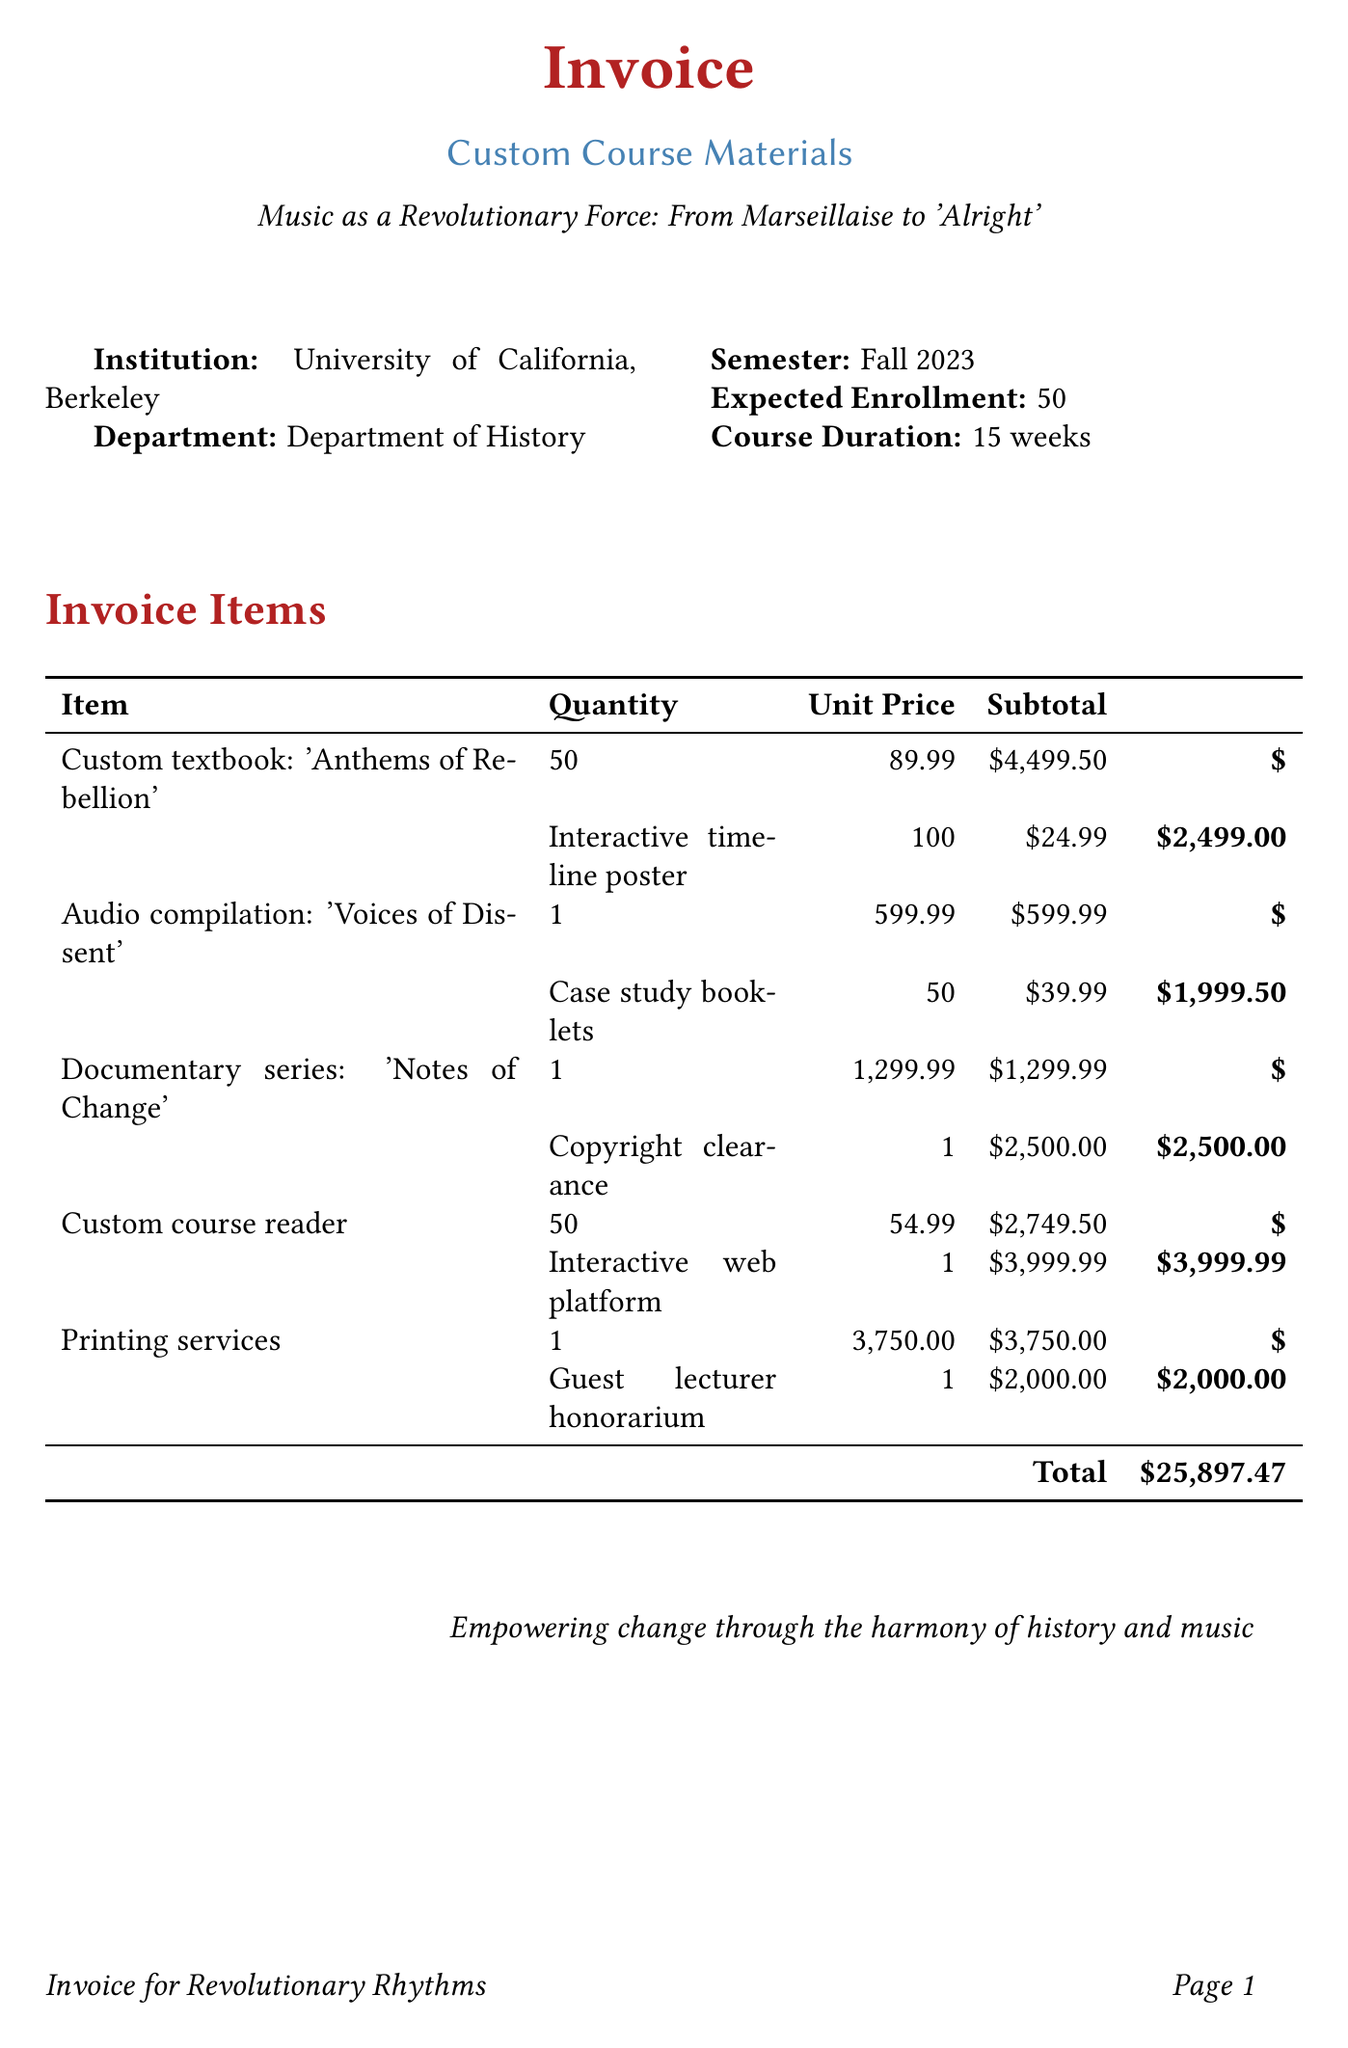what is the title of the custom textbook? The title is specified in the document as the custom textbook item.
Answer: Anthems of Rebellion: Music as a Catalyst for Political Change who is the guest lecturer? The invoice lists a guest lecturer and their relevant topic.
Answer: Dr. Angela Davis how many case study booklets were ordered? This information is retrieved from the invoice item details about booklets.
Answer: 50 what is the subtotal for the audio compilation? This can be found next to the listed price of the audio compilation in the invoice.
Answer: 599.99 what is the total amount due for the invoice? The total is provided at the bottom of the invoice, summing all subtotals listed in the document.
Answer: 25,897.47 what is the course duration? The course duration is specified under additional details in the invoice.
Answer: 15 weeks which institution is associated with the course? The invoice includes the name of the institution providing the course materials.
Answer: University of California, Berkeley what is included in the 'Interactive web platform'? This reflects the document's itemization of what the platform serves for the course.
Answer: Online component for student engagement and additional resources 